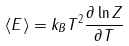Convert formula to latex. <formula><loc_0><loc_0><loc_500><loc_500>\langle E \rangle = k _ { B } T ^ { 2 } \frac { \partial \ln Z } { \partial T }</formula> 